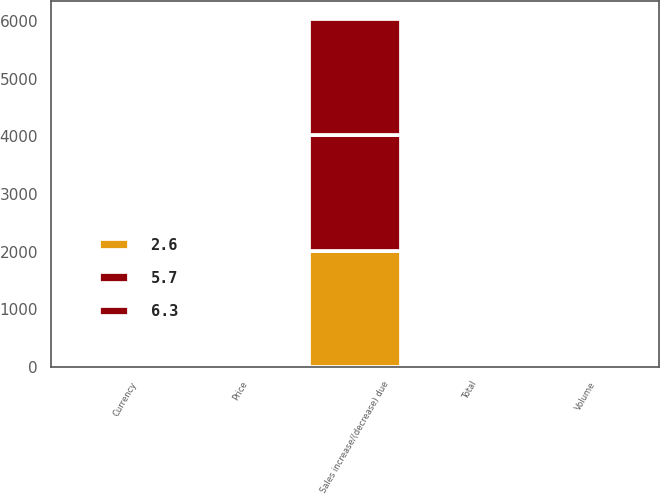Convert chart to OTSL. <chart><loc_0><loc_0><loc_500><loc_500><stacked_bar_chart><ecel><fcel>Sales increase/(decrease) due<fcel>Volume<fcel>Price<fcel>Currency<fcel>Total<nl><fcel>5.7<fcel>2017<fcel>8<fcel>2<fcel>0.3<fcel>6.3<nl><fcel>2.6<fcel>2016<fcel>3.2<fcel>0.7<fcel>1.3<fcel>2.6<nl><fcel>6.3<fcel>2015<fcel>1.2<fcel>0.6<fcel>7.5<fcel>5.7<nl></chart> 